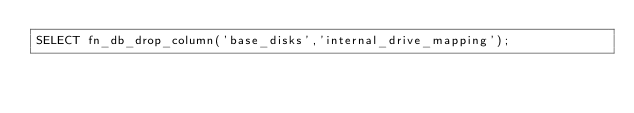<code> <loc_0><loc_0><loc_500><loc_500><_SQL_>SELECT fn_db_drop_column('base_disks','internal_drive_mapping');

</code> 